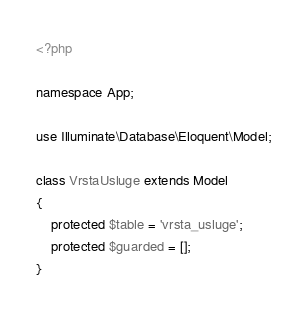<code> <loc_0><loc_0><loc_500><loc_500><_PHP_><?php

namespace App;

use Illuminate\Database\Eloquent\Model;

class VrstaUsluge extends Model
{
    protected $table = 'vrsta_usluge';
    protected $guarded = [];
}
</code> 